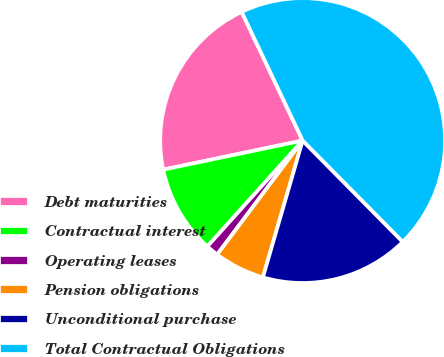<chart> <loc_0><loc_0><loc_500><loc_500><pie_chart><fcel>Debt maturities<fcel>Contractual interest<fcel>Operating leases<fcel>Pension obligations<fcel>Unconditional purchase<fcel>Total Contractual Obligations<nl><fcel>21.23%<fcel>10.06%<fcel>1.42%<fcel>5.74%<fcel>16.91%<fcel>44.63%<nl></chart> 